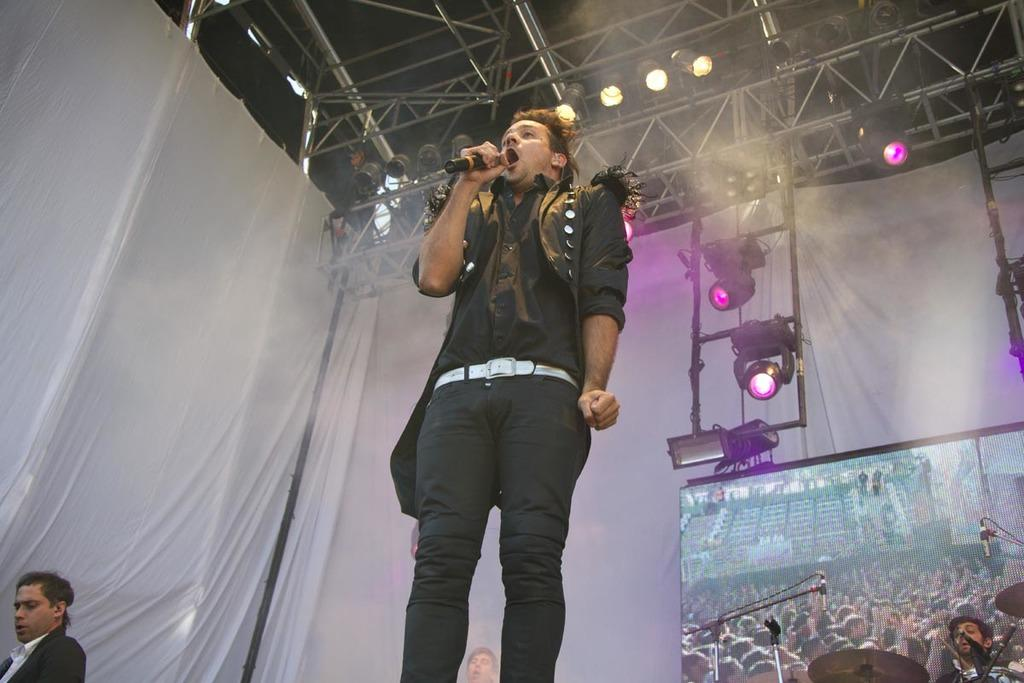What is the main subject of the image? The main subject of the image is a man. What is the man doing in the image? The man is standing and singing into a microphone. What is the man wearing in the image? The man is wearing a black coat and black trousers. What can be seen on the right side of the image? There are focus lights on the right side of the image. What type of patch is sewn onto the man's trousers in the image? There is no patch visible on the man's trousers in the image. What brand of toothpaste is advertised on the microphone in the image? There is no toothpaste or advertisement present on the microphone in the image. 